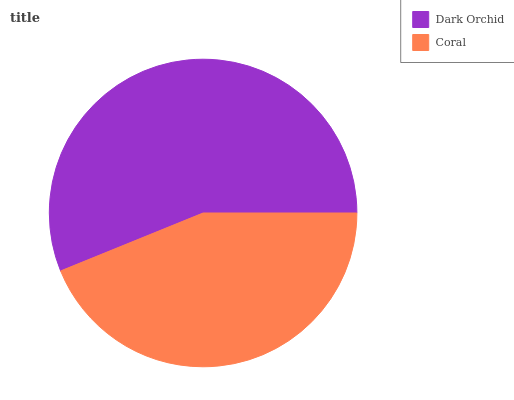Is Coral the minimum?
Answer yes or no. Yes. Is Dark Orchid the maximum?
Answer yes or no. Yes. Is Coral the maximum?
Answer yes or no. No. Is Dark Orchid greater than Coral?
Answer yes or no. Yes. Is Coral less than Dark Orchid?
Answer yes or no. Yes. Is Coral greater than Dark Orchid?
Answer yes or no. No. Is Dark Orchid less than Coral?
Answer yes or no. No. Is Dark Orchid the high median?
Answer yes or no. Yes. Is Coral the low median?
Answer yes or no. Yes. Is Coral the high median?
Answer yes or no. No. Is Dark Orchid the low median?
Answer yes or no. No. 